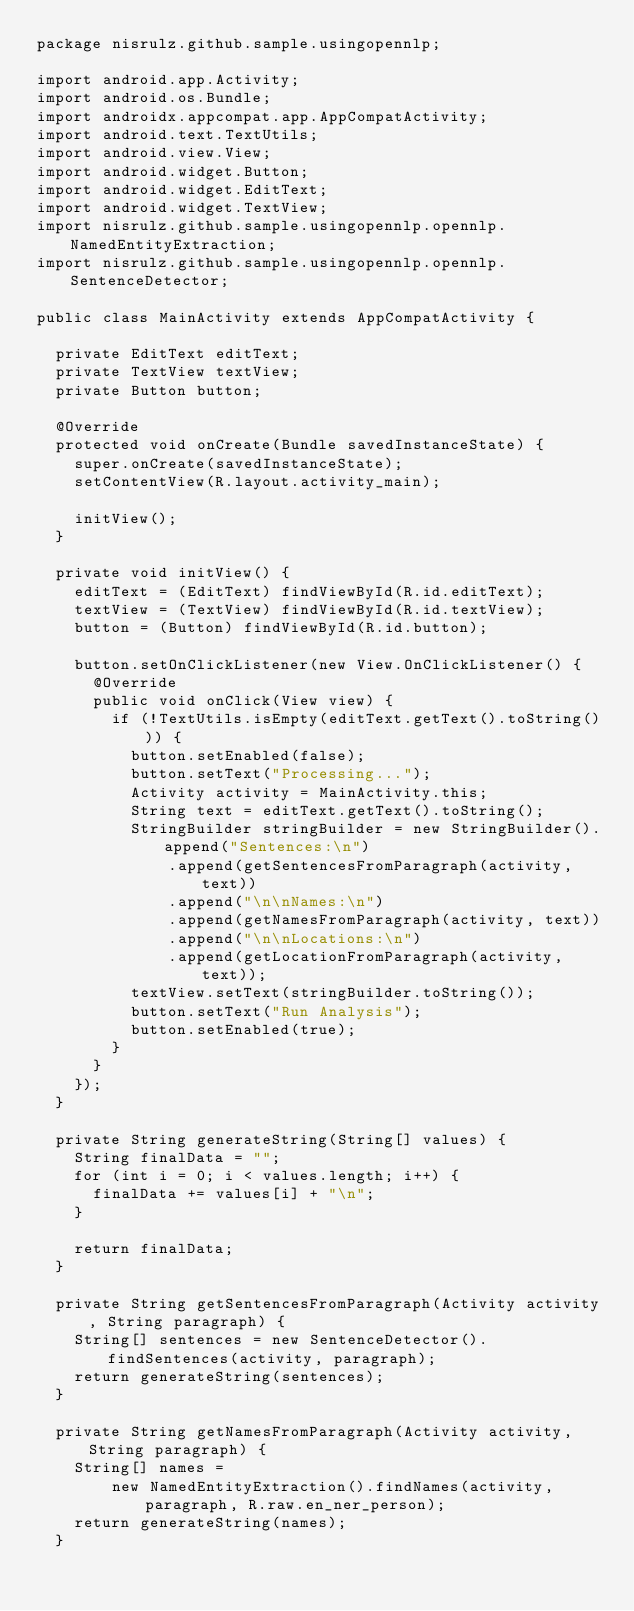Convert code to text. <code><loc_0><loc_0><loc_500><loc_500><_Java_>package nisrulz.github.sample.usingopennlp;

import android.app.Activity;
import android.os.Bundle;
import androidx.appcompat.app.AppCompatActivity;
import android.text.TextUtils;
import android.view.View;
import android.widget.Button;
import android.widget.EditText;
import android.widget.TextView;
import nisrulz.github.sample.usingopennlp.opennlp.NamedEntityExtraction;
import nisrulz.github.sample.usingopennlp.opennlp.SentenceDetector;

public class MainActivity extends AppCompatActivity {

  private EditText editText;
  private TextView textView;
  private Button button;

  @Override
  protected void onCreate(Bundle savedInstanceState) {
    super.onCreate(savedInstanceState);
    setContentView(R.layout.activity_main);

    initView();
  }

  private void initView() {
    editText = (EditText) findViewById(R.id.editText);
    textView = (TextView) findViewById(R.id.textView);
    button = (Button) findViewById(R.id.button);

    button.setOnClickListener(new View.OnClickListener() {
      @Override
      public void onClick(View view) {
        if (!TextUtils.isEmpty(editText.getText().toString())) {
          button.setEnabled(false);
          button.setText("Processing...");
          Activity activity = MainActivity.this;
          String text = editText.getText().toString();
          StringBuilder stringBuilder = new StringBuilder().append("Sentences:\n")
              .append(getSentencesFromParagraph(activity, text))
              .append("\n\nNames:\n")
              .append(getNamesFromParagraph(activity, text))
              .append("\n\nLocations:\n")
              .append(getLocationFromParagraph(activity, text));
          textView.setText(stringBuilder.toString());
          button.setText("Run Analysis");
          button.setEnabled(true);
        }
      }
    });
  }

  private String generateString(String[] values) {
    String finalData = "";
    for (int i = 0; i < values.length; i++) {
      finalData += values[i] + "\n";
    }

    return finalData;
  }

  private String getSentencesFromParagraph(Activity activity, String paragraph) {
    String[] sentences = new SentenceDetector().findSentences(activity, paragraph);
    return generateString(sentences);
  }

  private String getNamesFromParagraph(Activity activity, String paragraph) {
    String[] names =
        new NamedEntityExtraction().findNames(activity, paragraph, R.raw.en_ner_person);
    return generateString(names);
  }
</code> 